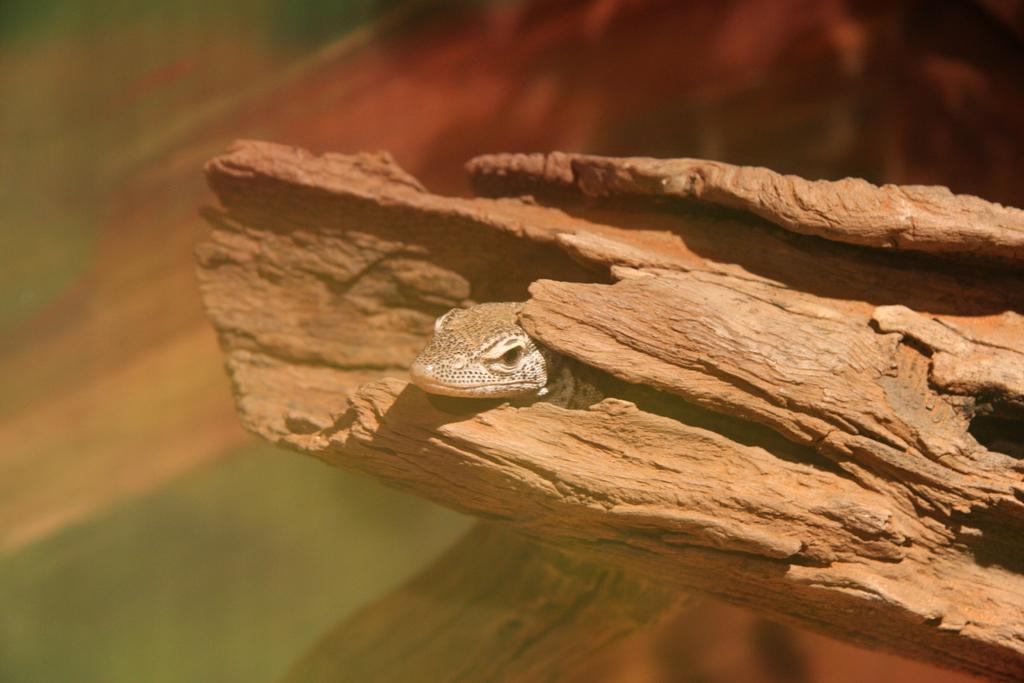What type of animal is in the image? There is a reptile in the image. Where is the reptile located? The reptile is on tree bark. What advice does the reptile's uncle give in the image? There is no uncle present in the image, and therefore no advice can be given. 